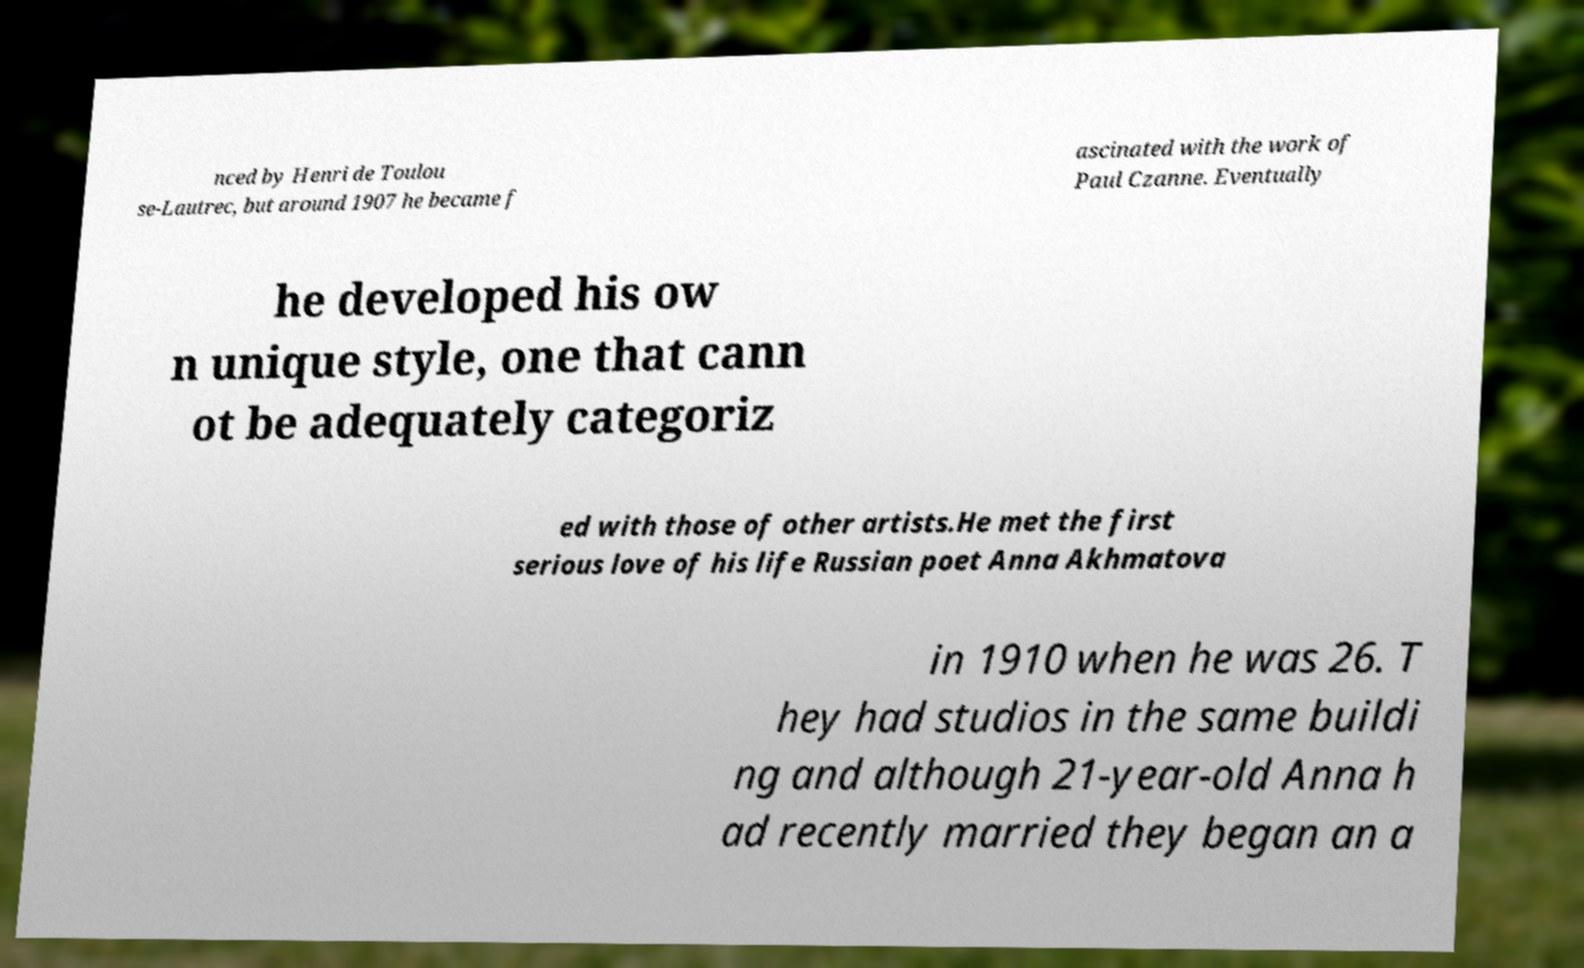There's text embedded in this image that I need extracted. Can you transcribe it verbatim? nced by Henri de Toulou se-Lautrec, but around 1907 he became f ascinated with the work of Paul Czanne. Eventually he developed his ow n unique style, one that cann ot be adequately categoriz ed with those of other artists.He met the first serious love of his life Russian poet Anna Akhmatova in 1910 when he was 26. T hey had studios in the same buildi ng and although 21-year-old Anna h ad recently married they began an a 